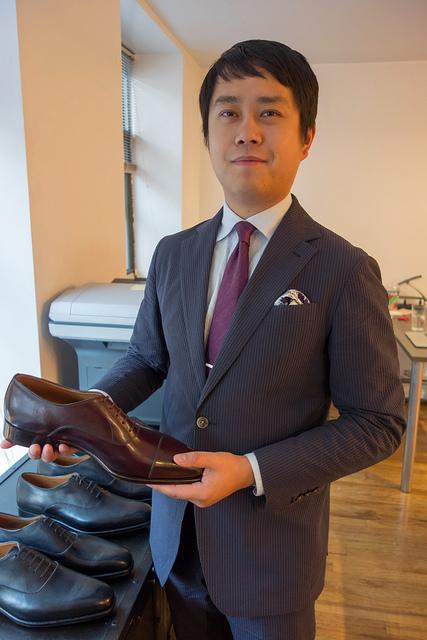What color is the man's suit?
Concise answer only. Gray. Is he dressed nice?
Concise answer only. Yes. What color is his tie?
Write a very short answer. Purple. What is this man holding?
Short answer required. Shoe. 